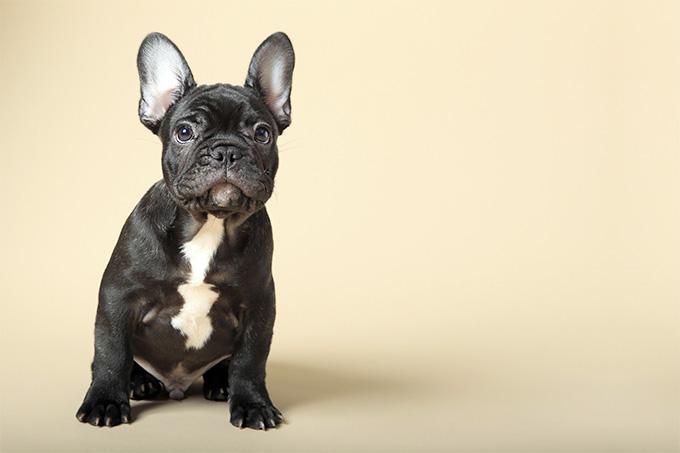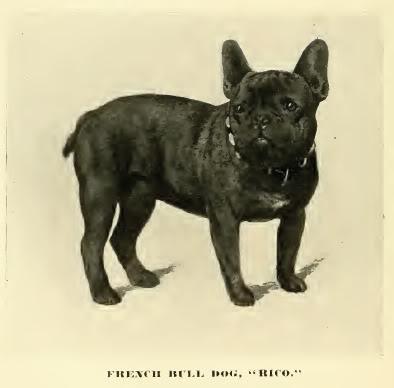The first image is the image on the left, the second image is the image on the right. Evaluate the accuracy of this statement regarding the images: "There are exactly three dogs standing on all fours.". Is it true? Answer yes or no. No. 